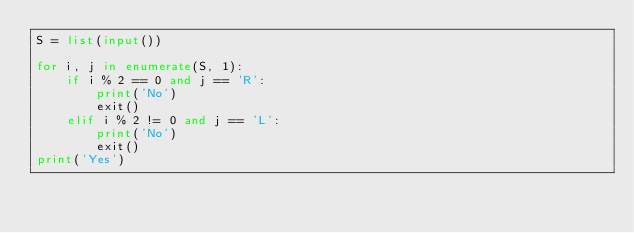<code> <loc_0><loc_0><loc_500><loc_500><_Python_>S = list(input())

for i, j in enumerate(S, 1):
    if i % 2 == 0 and j == 'R':
        print('No')
        exit()
    elif i % 2 != 0 and j == 'L':
        print('No')
        exit()
print('Yes')</code> 